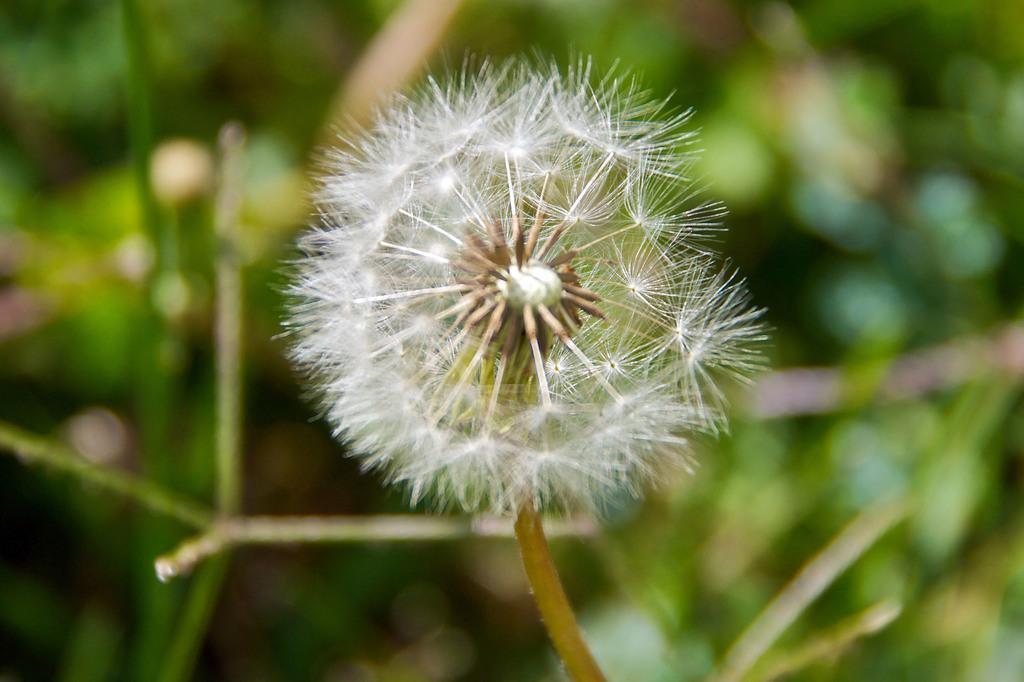How would you summarize this image in a sentence or two? In this picture I can see there is a dandelion attached to the stem and in the backdrop, it looks like there are plants and the backdrop is blurred. 